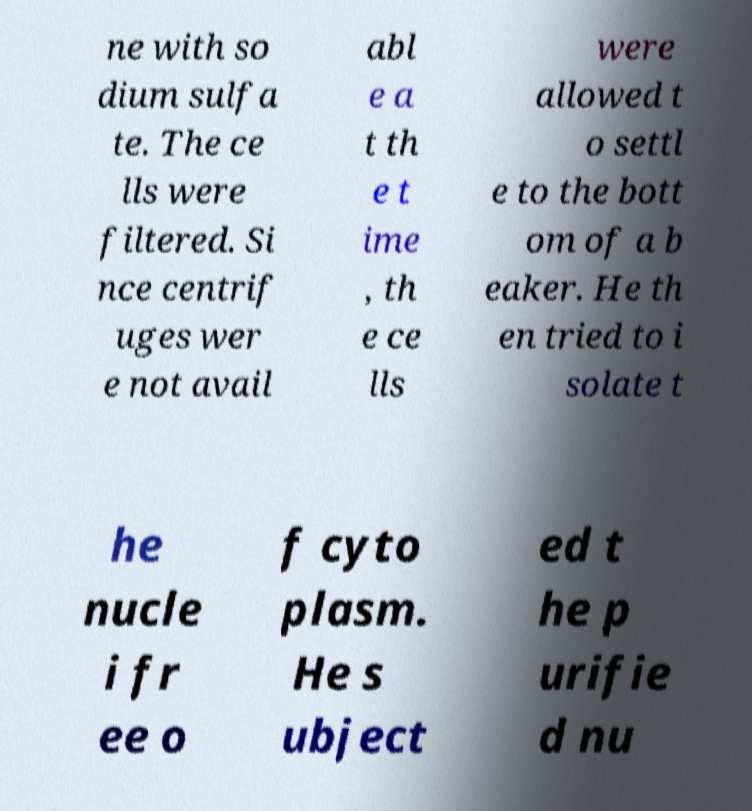Can you read and provide the text displayed in the image?This photo seems to have some interesting text. Can you extract and type it out for me? ne with so dium sulfa te. The ce lls were filtered. Si nce centrif uges wer e not avail abl e a t th e t ime , th e ce lls were allowed t o settl e to the bott om of a b eaker. He th en tried to i solate t he nucle i fr ee o f cyto plasm. He s ubject ed t he p urifie d nu 